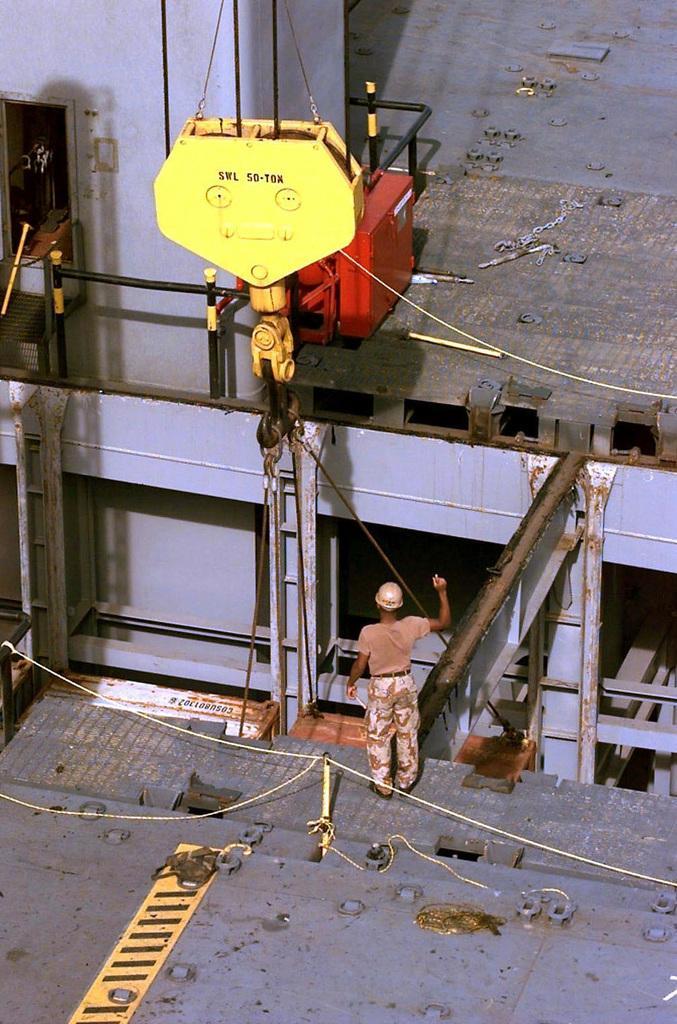Describe this image in one or two sentences. In this picture I can see a man is standing. The man is wearing helmet. Here I can see some machines and wires. 